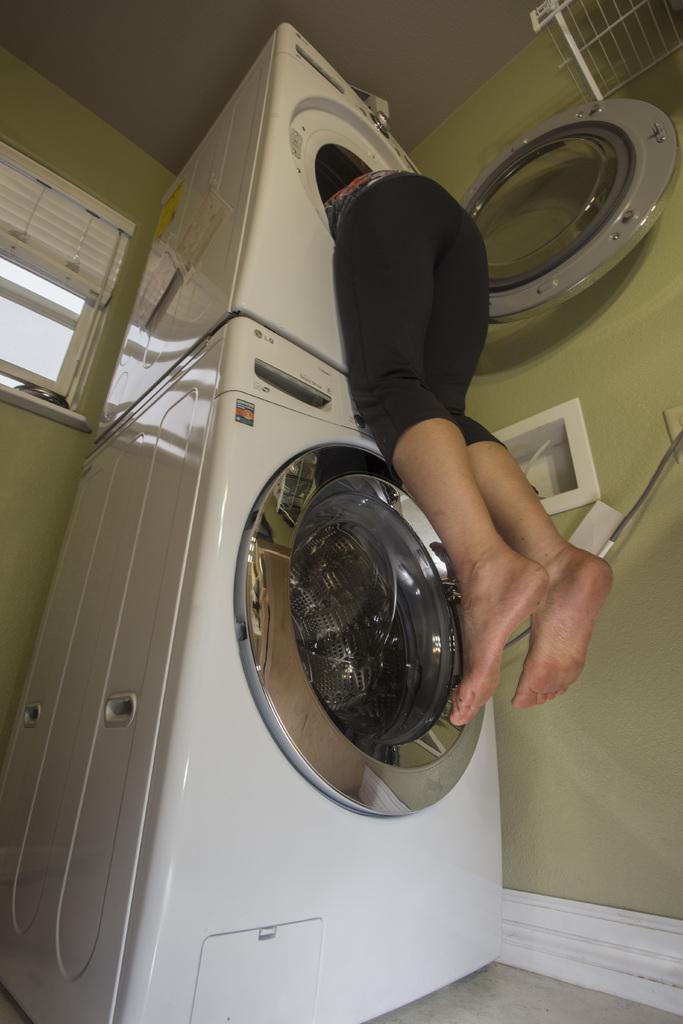In one or two sentences, can you explain what this image depicts? Here in this picture we can see washing machines present on the floor over there and we can see a person peeking through its door into it and on the wall we can see a window with window flaps present over there. 